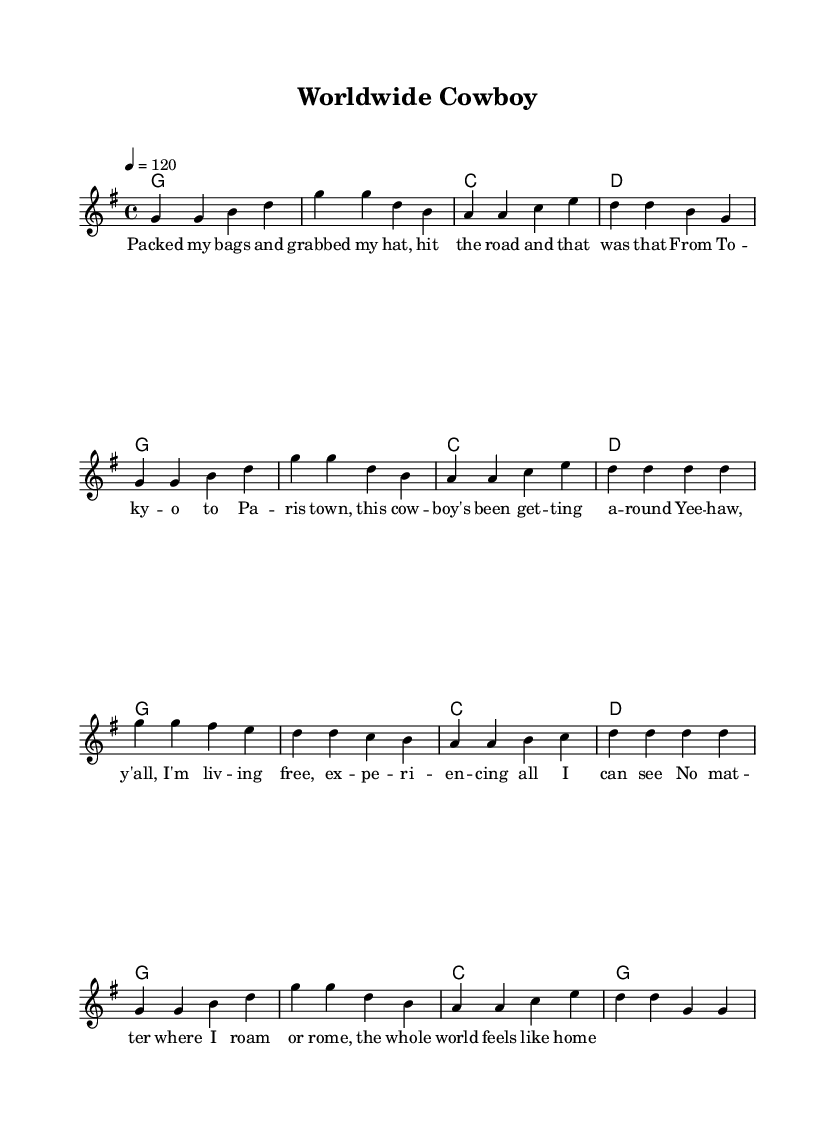What is the key signature of this music? The key signature is G major, which has one sharp (F#). This can be deduced from the global block where the key is indicated as g major.
Answer: G major What is the time signature of this music? The time signature is 4/4. It is clearly specified in the global block, which tells us there are four beats per measure.
Answer: 4/4 What is the tempo marking for this piece? The tempo marking is 120 beats per minute. This is indicated within the global section where the tempo is specified as 4 = 120.
Answer: 120 How many measures are there in the melody? The melody consists of 12 measures. By counting the groups of symbols separated by vertical lines in the melody, we can identify each measure.
Answer: 12 What type of song is "Worldwide Cowboy"? The song is an upbeat country song. The lyrics and title suggest themes of travel and cultural experiences, which are characteristic of country music.
Answer: Upbeat country Which city is mentioned as the starting point in the lyrics? The lyrics mention "To -- ky -- o" as the starting point, referring to Tokyo. This can be found in the first line of the verse.
Answer: Tokyo What emotion is expressed in the chorus of the song? The chorus expresses a feeling of freedom and adventure, as evidenced by the lyrics discussing living free and experiencing the world. This is a common theme in country music.
Answer: Freedom 